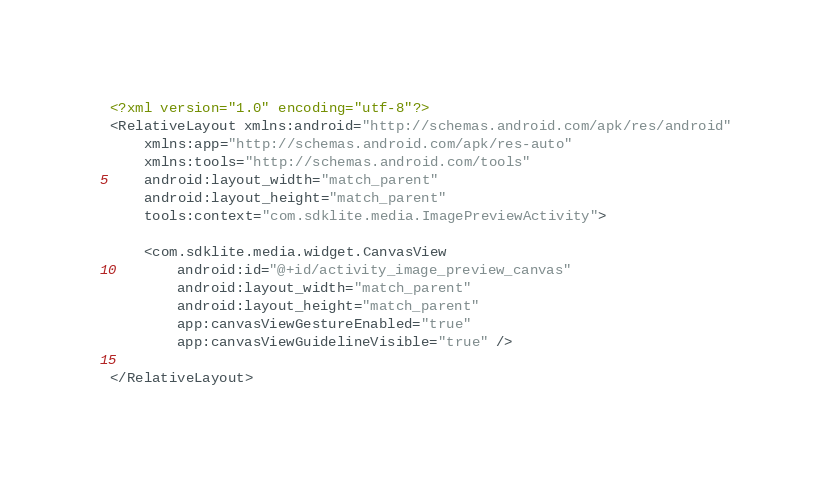Convert code to text. <code><loc_0><loc_0><loc_500><loc_500><_XML_><?xml version="1.0" encoding="utf-8"?>
<RelativeLayout xmlns:android="http://schemas.android.com/apk/res/android"
    xmlns:app="http://schemas.android.com/apk/res-auto"
    xmlns:tools="http://schemas.android.com/tools"
    android:layout_width="match_parent"
    android:layout_height="match_parent"
    tools:context="com.sdklite.media.ImagePreviewActivity">

    <com.sdklite.media.widget.CanvasView
        android:id="@+id/activity_image_preview_canvas"
        android:layout_width="match_parent"
        android:layout_height="match_parent"
        app:canvasViewGestureEnabled="true"
        app:canvasViewGuidelineVisible="true" />

</RelativeLayout>
</code> 